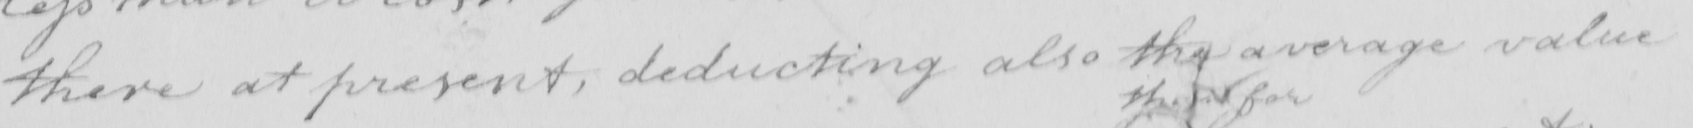What does this handwritten line say? there at present , deducting also the average value 